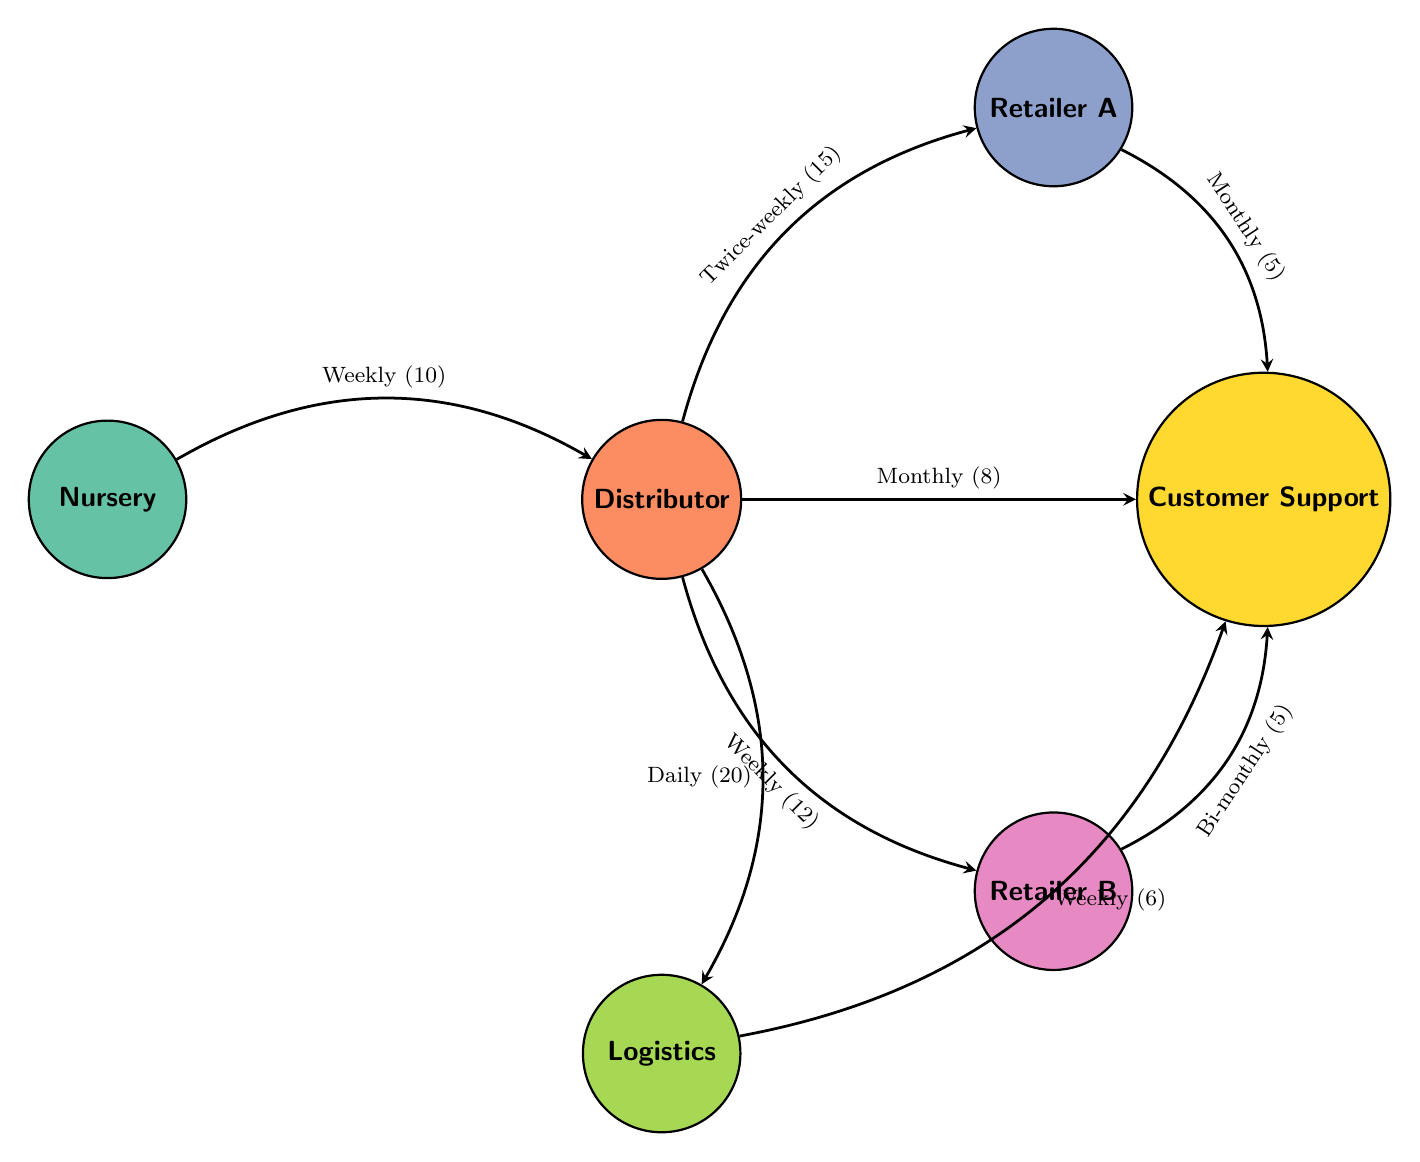What is the total number of nodes in the diagram? The diagram has six distinct nodes which include: Nursery, Distributor, Retailer A, Retailer B, Logistics, and Customer Support.
Answer: 6 What type of communication does the Nursery have with the Distributor? The link between the Nursery and Distributor specifies that they communicate through weekly inventory reports and order updates.
Answer: Weekly inventory reports and order updates How many links are directed from the Distributor? The Distributor has four links directed towards Retailer A, Retailer B, Logistics, and Customer Support, indicating multiple communication channels.
Answer: 4 Which retailer has the most frequent communication with the Distributor? The link from the Distributor to Retailer A indicates a twice-weekly communication schedule, which is more frequent than any other retailer connection.
Answer: Twice-weekly What is the nature of the communication between Retailer B and Customer Support? The connection between Retailer B and Customer Support indicates that communication occurs bi-monthly with queries and feedback on plant quality.
Answer: Bi-monthly queries and feedback on plant quality What is the frequency of communication for logistics to Customer Support? The link between Logistics and Customer Support states that this communication occurs weekly, as specified in the diagram.
Answer: Weekly How often does the Distributor coordinate shipments with Logistics? The communication flow from the Distributor to Logistics indicates that they coordinate shipments on a daily basis as per the diagram's description.
Answer: Daily shipment coordination Which node has the least amount of outgoing communication value? The Customer Support node has only three connections, one of which is from Retailer A and another from Retailer B, each valued less than other connections.
Answer: 5 Explain the overall flow of communication starting from the Nursery to the retailers. The Nursery sends weekly reports to the Distributor, who processes orders and communicates twice-weekly with Retailer A, and weekly with Retailer B. Thus, the flow of information starts from Nursery to Distributor and branches out to both retailers.
Answer: Nursery to Distributor, then to Retailer A and Retailer B 